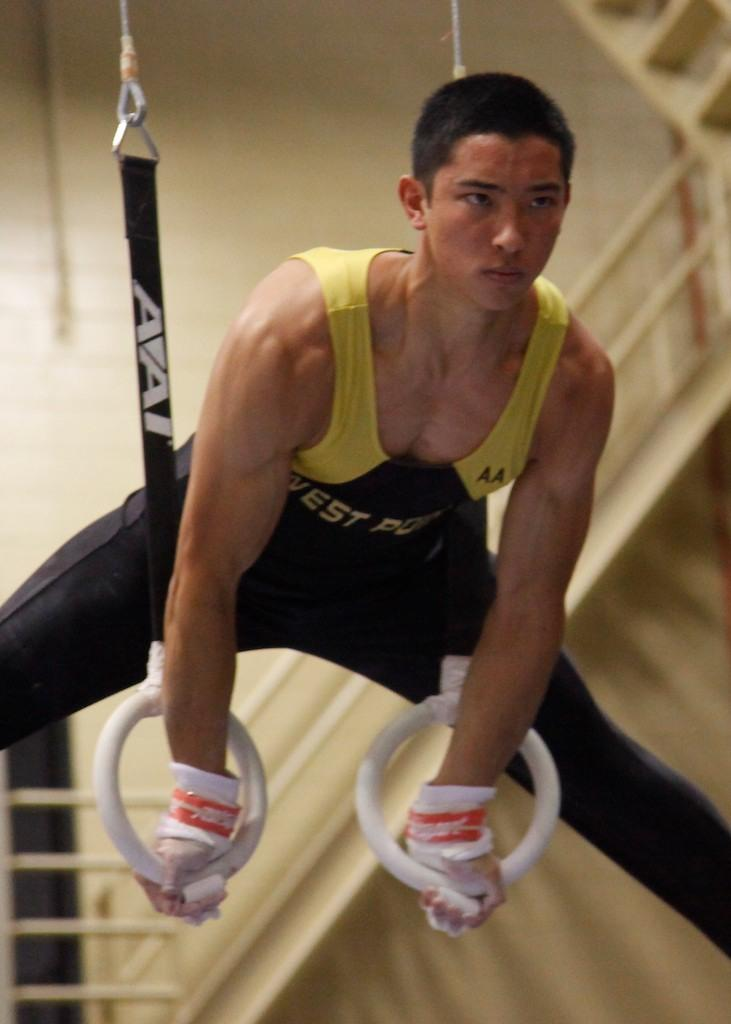Provide a one-sentence caption for the provided image. A gymnast from West Point balances on 2 suspended rings. 